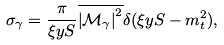Convert formula to latex. <formula><loc_0><loc_0><loc_500><loc_500>\sigma _ { \gamma } = \frac { \pi } { \xi y S } \overline { { \left | \mathcal { M } _ { \gamma } \right | } ^ { 2 } } \delta ( \xi y S - m _ { t } ^ { 2 } ) ,</formula> 